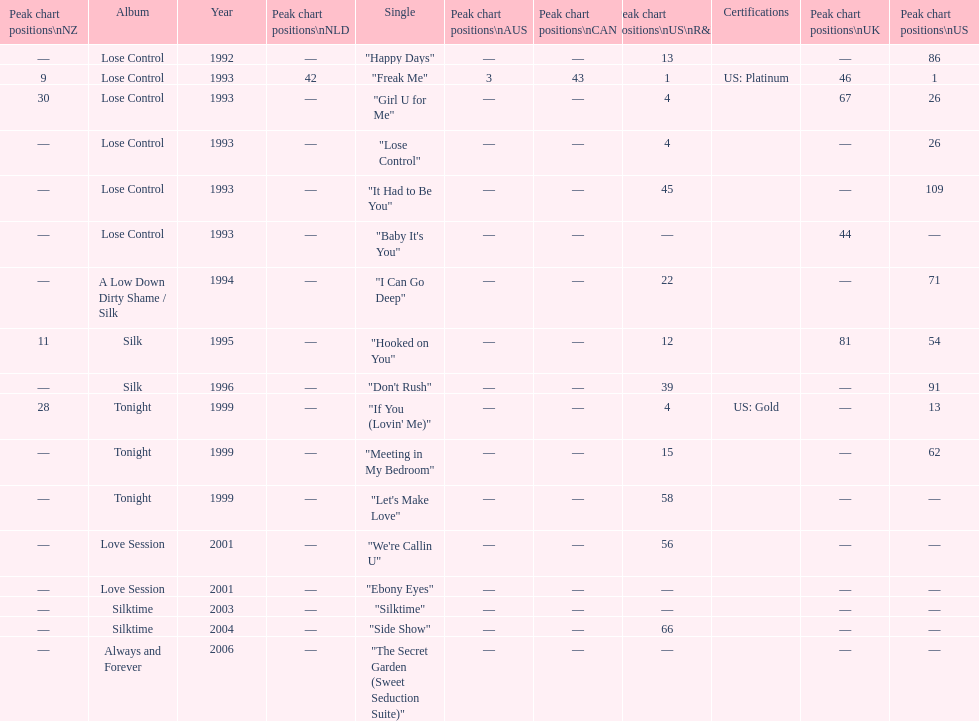Compare "i can go deep" with "don't rush". which was higher on the us and us r&b charts? "I Can Go Deep". 